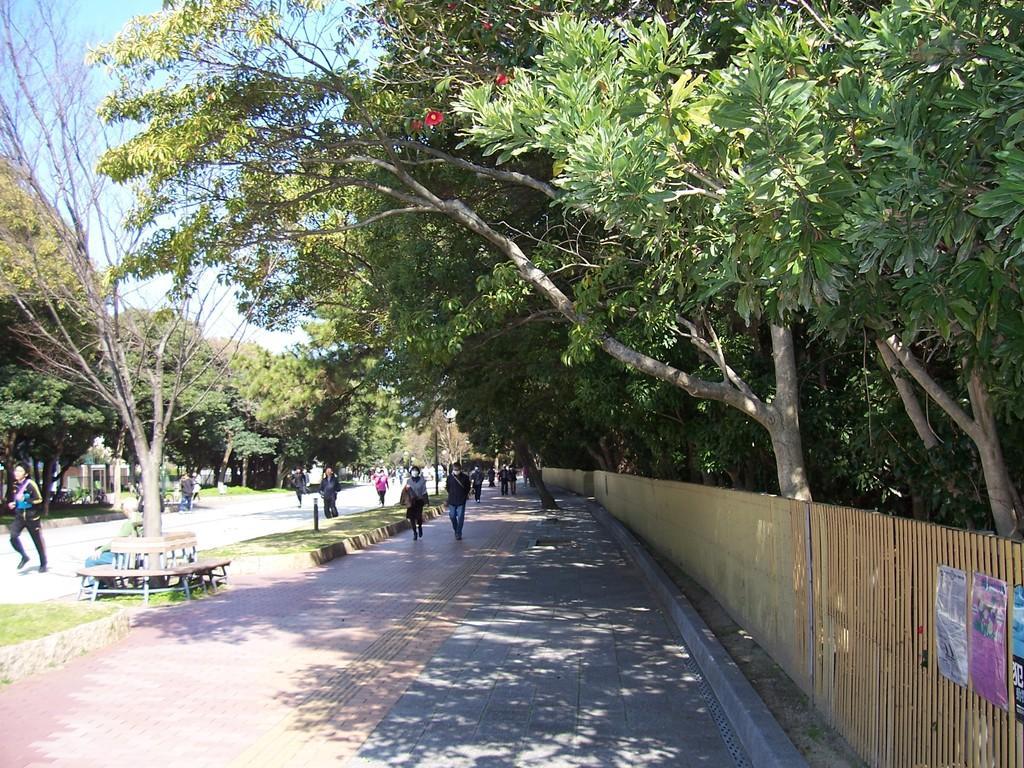How would you summarize this image in a sentence or two? In the image we can see there are lot of people standing on the footpath and road. Behind there are lot of trees in the area. 